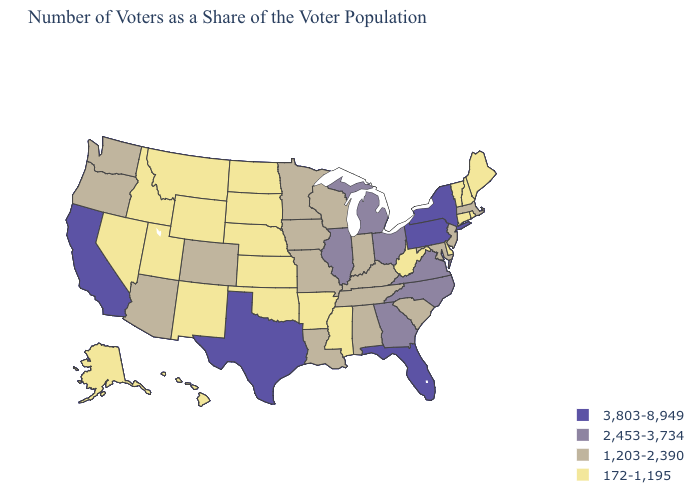What is the value of Alaska?
Quick response, please. 172-1,195. What is the highest value in states that border Vermont?
Concise answer only. 3,803-8,949. What is the lowest value in the USA?
Write a very short answer. 172-1,195. Which states have the highest value in the USA?
Keep it brief. California, Florida, New York, Pennsylvania, Texas. Among the states that border Kentucky , does West Virginia have the lowest value?
Concise answer only. Yes. Does Nebraska have the lowest value in the MidWest?
Give a very brief answer. Yes. Does Illinois have the same value as Michigan?
Write a very short answer. Yes. Name the states that have a value in the range 3,803-8,949?
Write a very short answer. California, Florida, New York, Pennsylvania, Texas. What is the value of Florida?
Be succinct. 3,803-8,949. Name the states that have a value in the range 172-1,195?
Quick response, please. Alaska, Arkansas, Connecticut, Delaware, Hawaii, Idaho, Kansas, Maine, Mississippi, Montana, Nebraska, Nevada, New Hampshire, New Mexico, North Dakota, Oklahoma, Rhode Island, South Dakota, Utah, Vermont, West Virginia, Wyoming. Name the states that have a value in the range 1,203-2,390?
Be succinct. Alabama, Arizona, Colorado, Indiana, Iowa, Kentucky, Louisiana, Maryland, Massachusetts, Minnesota, Missouri, New Jersey, Oregon, South Carolina, Tennessee, Washington, Wisconsin. What is the value of Delaware?
Quick response, please. 172-1,195. Does Wisconsin have the lowest value in the MidWest?
Quick response, please. No. What is the lowest value in states that border Michigan?
Keep it brief. 1,203-2,390. How many symbols are there in the legend?
Be succinct. 4. 